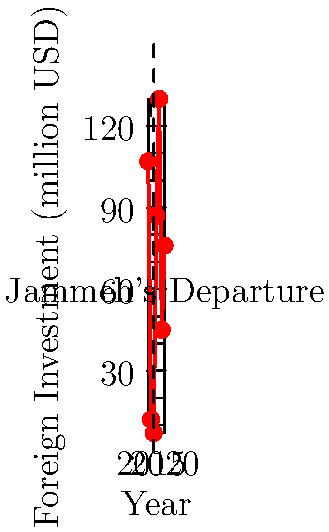Analyzing the line chart depicting foreign investment in Gambia from 2014 to 2020, what conclusion can be drawn about the impact of Yahya Jammeh's departure on foreign investment trends, and how does this reflect on the economic policies of the subsequent administration? To analyze the impact of Yahya Jammeh's departure on foreign investment in Gambia, we need to follow these steps:

1. Identify the year of Jammeh's departure: 2016 (marked on the chart)

2. Compare pre-departure and post-departure trends:
   - Pre-departure (2014-2016): Sharp decline from $107 million to $7 million
   - Post-departure (2017-2020): Immediate surge to $87 million, then fluctuating

3. Observe the immediate effect:
   - 2017 saw a significant increase to $87 million, over 12 times the 2016 level

4. Analyze the post-departure trend:
   - 2018: Further increase to $130 million
   - 2019-2020: Decline to $45 million, then slight recovery to $76 million

5. Draw conclusions:
   - Jammeh's departure correlated with an immediate and substantial increase in foreign investment
   - The subsequent years show volatility, indicating potential policy uncertainties or external factors affecting investor confidence

6. Reflect on the subsequent administration:
   - Initial surge suggests improved investor confidence post-Jammeh
   - Fluctuations in later years may indicate challenges in maintaining consistent economic policies or attracting sustained foreign investment

The data suggests that while Jammeh's departure had an immediate positive impact on foreign investment, the subsequent administration has faced challenges in maintaining a consistent upward trend, pointing to potential areas for improvement in economic policies and investor relations.
Answer: Jammeh's departure led to an initial surge in foreign investment, but subsequent fluctuations indicate challenges in maintaining consistent growth under the new administration. 